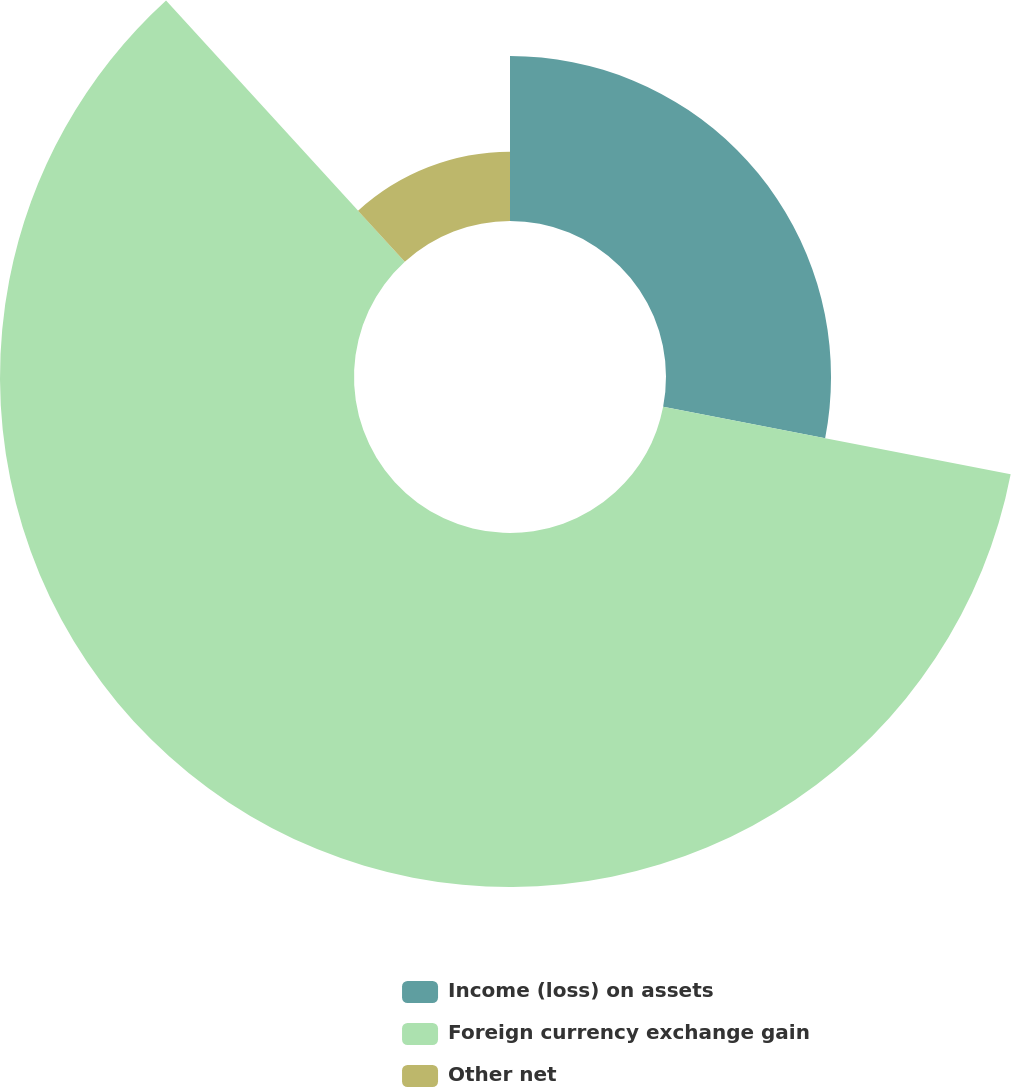Convert chart. <chart><loc_0><loc_0><loc_500><loc_500><pie_chart><fcel>Income (loss) on assets<fcel>Foreign currency exchange gain<fcel>Other net<nl><fcel>28.05%<fcel>60.17%<fcel>11.78%<nl></chart> 